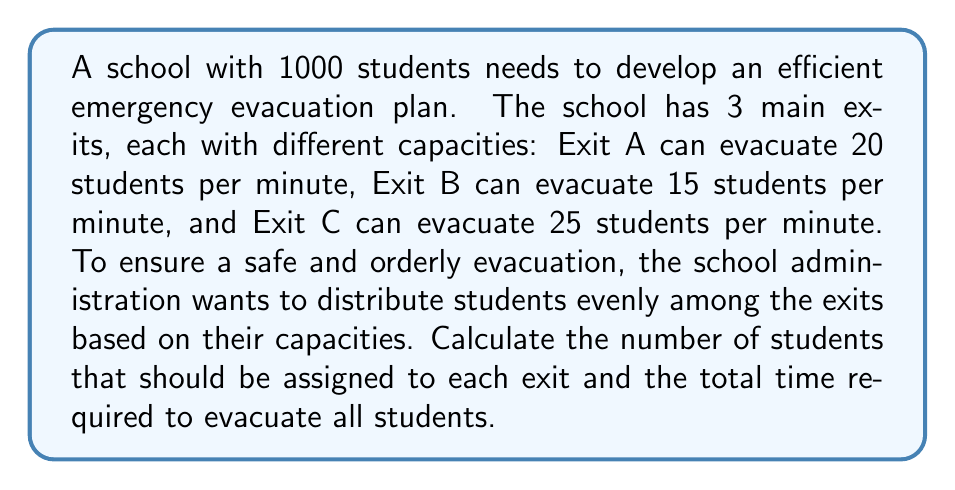Can you answer this question? 1. Calculate the total evacuation capacity per minute:
   Exit A: 20 students/min
   Exit B: 15 students/min
   Exit C: 25 students/min
   Total capacity = $20 + 15 + 25 = 60$ students/min

2. Calculate the proportion of students for each exit:
   Exit A: $\frac{20}{60} = \frac{1}{3}$
   Exit B: $\frac{15}{60} = \frac{1}{4}$
   Exit C: $\frac{25}{60} = \frac{5}{12}$

3. Assign students to each exit based on proportions:
   Exit A: $1000 \times \frac{1}{3} = 333.33$ students
   Exit B: $1000 \times \frac{1}{4} = 250$ students
   Exit C: $1000 \times \frac{5}{12} = 416.67$ students

4. Round the numbers to ensure all students are accounted for:
   Exit A: 333 students
   Exit B: 250 students
   Exit C: 417 students

5. Calculate evacuation time for each exit:
   Exit A: $\frac{333}{20} = 16.65$ minutes
   Exit B: $\frac{250}{15} = 16.67$ minutes
   Exit C: $\frac{417}{25} = 16.68$ minutes

The total evacuation time will be the maximum of these times, which is 16.68 minutes.
Answer: Exit A: 333 students, Exit B: 250 students, Exit C: 417 students; Total evacuation time: 16.68 minutes 